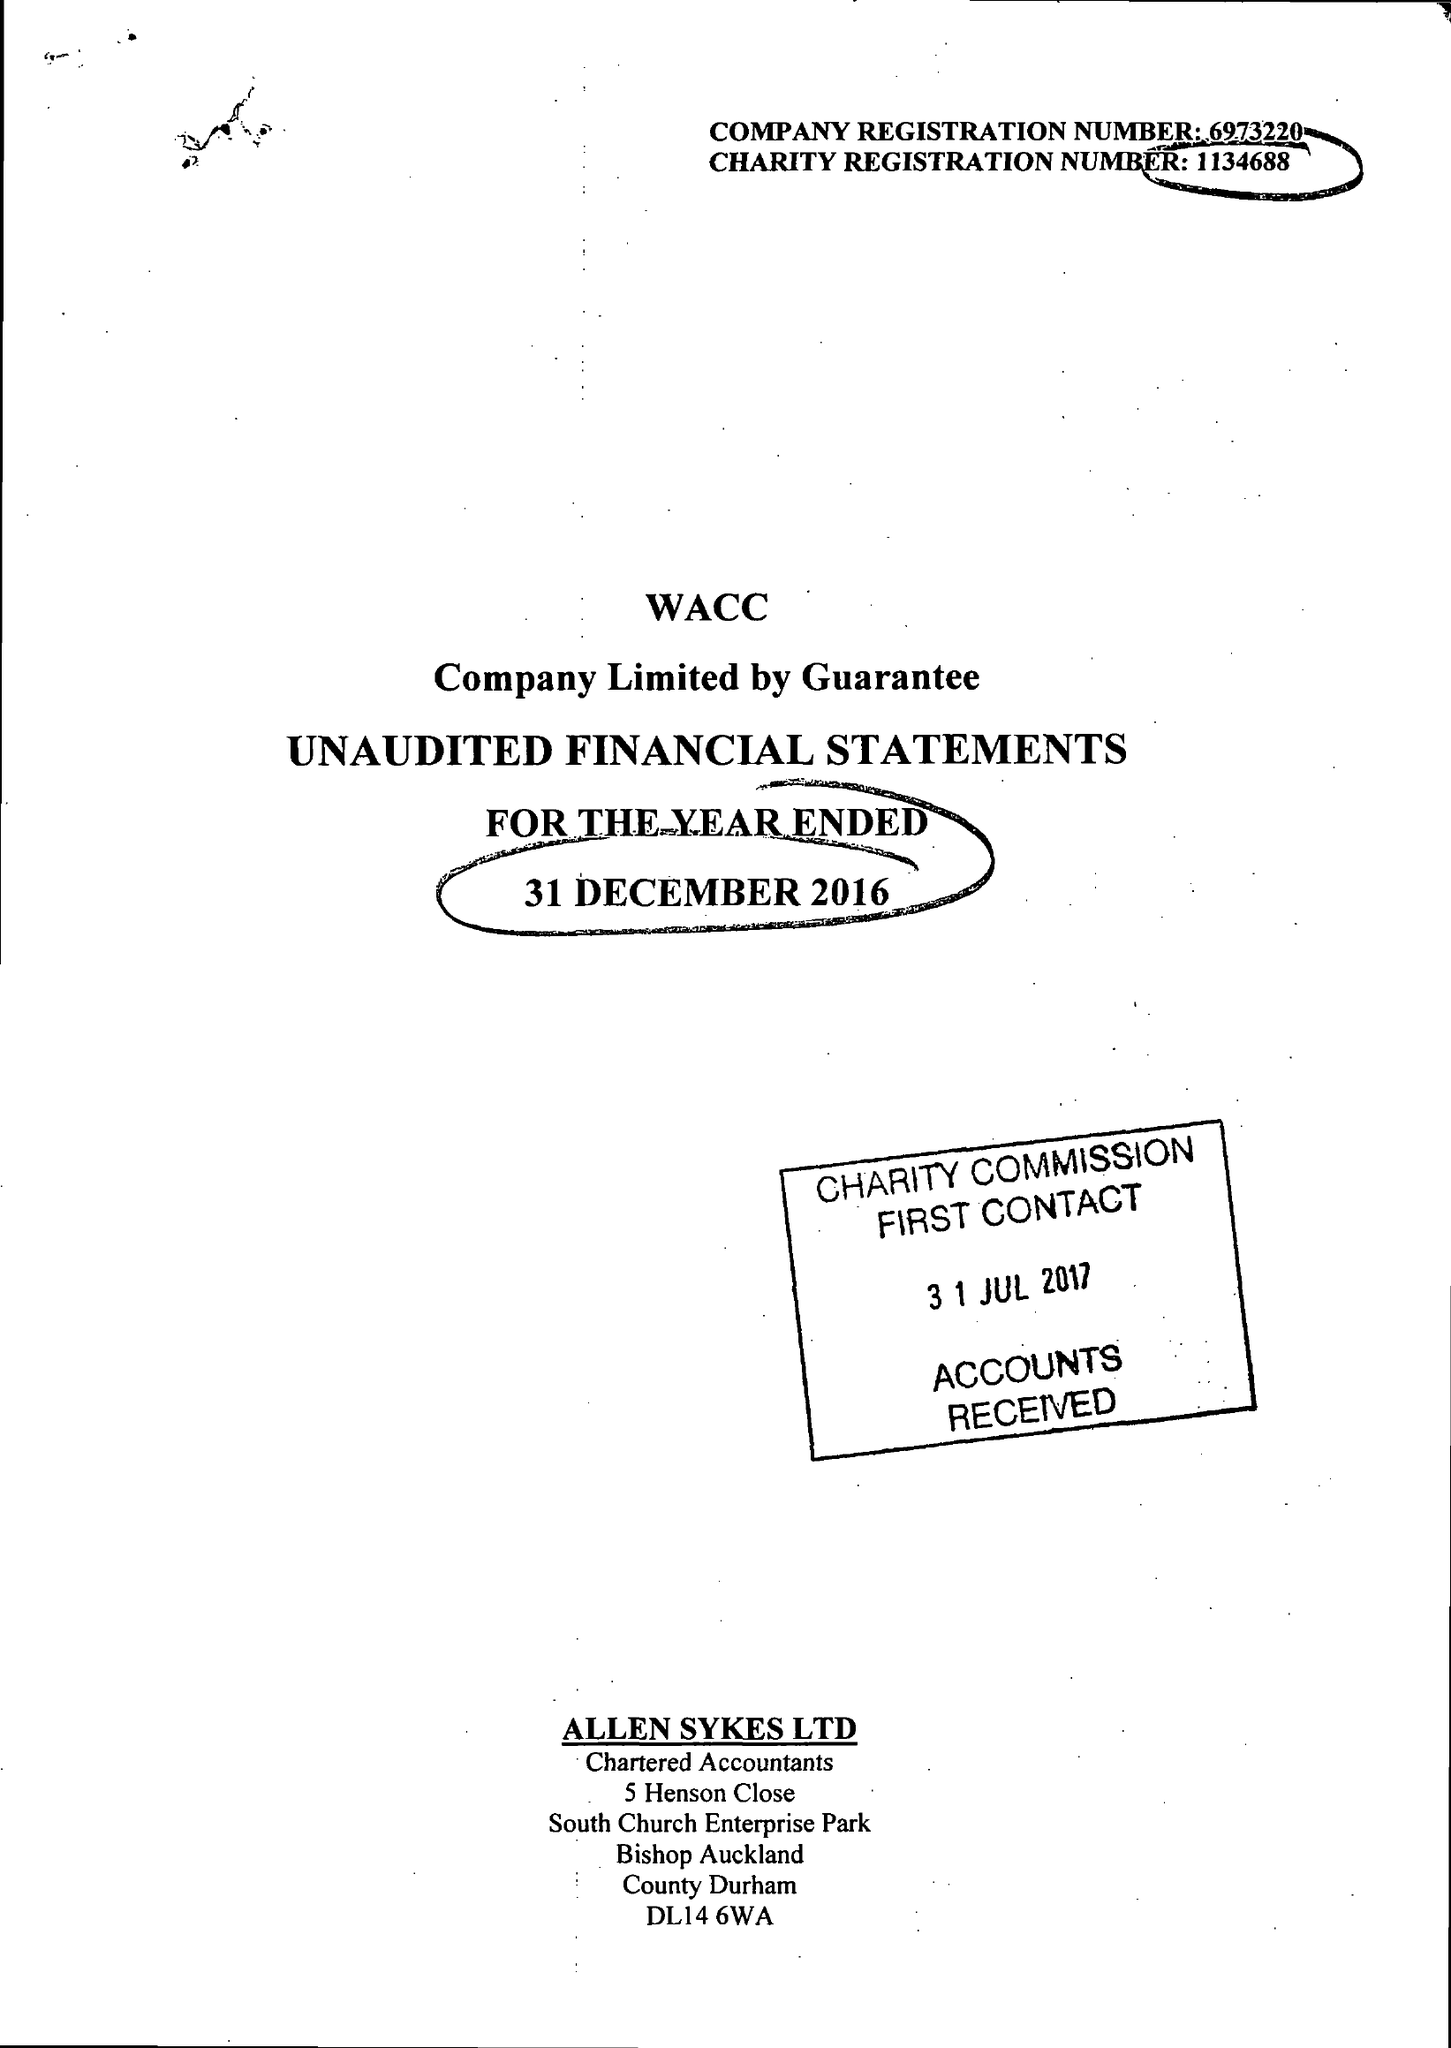What is the value for the spending_annually_in_british_pounds?
Answer the question using a single word or phrase. 79278.00 